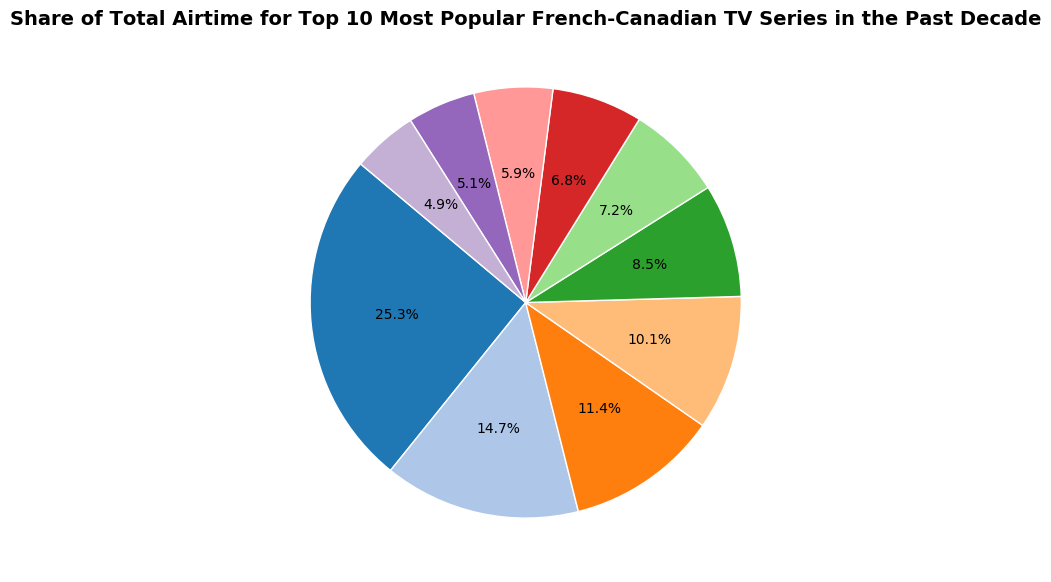Which TV series has the largest share of total airtime? The pie chart indicates that "District 31" has the largest portion of the pie, taking up 25.3% of the total airtime.
Answer: District 31 What is the combined share of total airtime for "Unité 9" and "Les Pays d'en Haut"? The pie chart shows that "Unité 9" has a share of 14.7% and "Les Pays d'en Haut" has 11.4%. Adding them together, the combined share is 14.7% + 11.4% = 26.1%.
Answer: 26.1% Which two TV series have the closest shares of total airtime? By visually comparing the segments, "Les Simone" (5.1%) and "L'Échappée" (4.9%) have the closest values, differing by only 0.2%.
Answer: Les Simone and L'Échappée Is the share of "District 31" more than double the share of "Toute la vie"? "District 31" has a share of 25.3% and "Toute la vie" has 5.9%. Doubling the share of "Toute la vie" would be 2 * 5.9% = 11.8%. Since 25.3% is more than 11.8%, the share of "District 31" is indeed more than double.
Answer: Yes What is the difference between the highest and lowest shares of total airtime? The highest share is "District 31" with 25.3% and the lowest share is "L'Échappée" with 4.9%. The difference is 25.3% - 4.9% = 20.4%.
Answer: 20.4% Which TV series holds the second-largest share of airtime? The pie chart shows that "Unité 9" holds the second-largest share of total airtime with 14.7%.
Answer: Unité 9 How many series have a share of total airtime less than 10%? By examining the pie chart, "La Galère" (8.5%), "Fugueuse" (7.2%), "19-2" (6.8%), "Toute la vie" (5.9%), "Les Simone" (5.1%), and "L'Échappée" (4.9%) all have shares below 10%. This totals to 6 series.
Answer: 6 What is the combined share of total airtime for the bottom three TV series? The bottom three TV series are "Les Simone" (5.1%), "L'Échappée" (4.9%), and "Toute la vie" (5.9%). Adding these, the combined share is 5.1% + 4.9% + 5.9% = 15.9%.
Answer: 15.9% Does "Les Beaux Malaises" have a greater share of total airtime than "Fugueuse" and "19-2" combined? "Les Beaux Malaises" has a share of 10.1%. "Fugueuse" has 7.2% and "19-2" has 6.8%. Combined, "Fugueuse" and "19-2" have 7.2% + 6.8% = 14.0%. Since 10.1% is less than 14.0%, "Les Beaux Malaises" does not have a greater share.
Answer: No Which series has a share of total airtime just under that of "Les Beaux Malaises"? The pie chart indicates that "Les Beaux Malaises" has a share of 10.1% and the next closest series is "La Galère" with 8.5%.
Answer: La Galère 